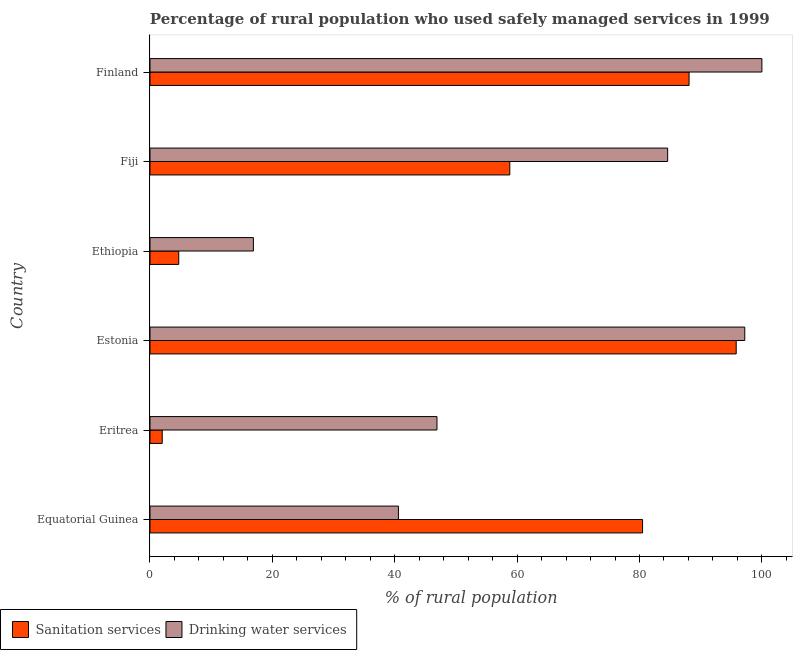Are the number of bars per tick equal to the number of legend labels?
Keep it short and to the point. Yes. What is the label of the 6th group of bars from the top?
Keep it short and to the point. Equatorial Guinea. In how many cases, is the number of bars for a given country not equal to the number of legend labels?
Make the answer very short. 0. Across all countries, what is the maximum percentage of rural population who used drinking water services?
Provide a succinct answer. 100. In which country was the percentage of rural population who used drinking water services maximum?
Your answer should be compact. Finland. In which country was the percentage of rural population who used sanitation services minimum?
Your answer should be very brief. Eritrea. What is the total percentage of rural population who used sanitation services in the graph?
Your answer should be very brief. 329.9. What is the difference between the percentage of rural population who used sanitation services in Equatorial Guinea and that in Eritrea?
Your answer should be compact. 78.5. What is the difference between the percentage of rural population who used drinking water services in Estonia and the percentage of rural population who used sanitation services in Fiji?
Ensure brevity in your answer.  38.4. What is the average percentage of rural population who used sanitation services per country?
Ensure brevity in your answer.  54.98. What is the difference between the percentage of rural population who used drinking water services and percentage of rural population who used sanitation services in Eritrea?
Your answer should be very brief. 44.9. In how many countries, is the percentage of rural population who used sanitation services greater than 68 %?
Your answer should be compact. 3. What is the ratio of the percentage of rural population who used drinking water services in Estonia to that in Finland?
Your answer should be compact. 0.97. Is the percentage of rural population who used drinking water services in Equatorial Guinea less than that in Estonia?
Keep it short and to the point. Yes. Is the difference between the percentage of rural population who used drinking water services in Eritrea and Fiji greater than the difference between the percentage of rural population who used sanitation services in Eritrea and Fiji?
Your answer should be very brief. Yes. What is the difference between the highest and the second highest percentage of rural population who used sanitation services?
Keep it short and to the point. 7.7. What is the difference between the highest and the lowest percentage of rural population who used sanitation services?
Provide a short and direct response. 93.8. In how many countries, is the percentage of rural population who used drinking water services greater than the average percentage of rural population who used drinking water services taken over all countries?
Your answer should be compact. 3. Is the sum of the percentage of rural population who used sanitation services in Equatorial Guinea and Ethiopia greater than the maximum percentage of rural population who used drinking water services across all countries?
Provide a short and direct response. No. What does the 2nd bar from the top in Eritrea represents?
Keep it short and to the point. Sanitation services. What does the 2nd bar from the bottom in Finland represents?
Give a very brief answer. Drinking water services. What is the difference between two consecutive major ticks on the X-axis?
Offer a very short reply. 20. Are the values on the major ticks of X-axis written in scientific E-notation?
Ensure brevity in your answer.  No. Does the graph contain grids?
Your answer should be very brief. No. Where does the legend appear in the graph?
Ensure brevity in your answer.  Bottom left. How many legend labels are there?
Ensure brevity in your answer.  2. What is the title of the graph?
Ensure brevity in your answer.  Percentage of rural population who used safely managed services in 1999. Does "Automatic Teller Machines" appear as one of the legend labels in the graph?
Ensure brevity in your answer.  No. What is the label or title of the X-axis?
Your answer should be very brief. % of rural population. What is the % of rural population of Sanitation services in Equatorial Guinea?
Keep it short and to the point. 80.5. What is the % of rural population of Drinking water services in Equatorial Guinea?
Ensure brevity in your answer.  40.6. What is the % of rural population in Drinking water services in Eritrea?
Make the answer very short. 46.9. What is the % of rural population in Sanitation services in Estonia?
Make the answer very short. 95.8. What is the % of rural population in Drinking water services in Estonia?
Make the answer very short. 97.2. What is the % of rural population in Drinking water services in Ethiopia?
Keep it short and to the point. 16.9. What is the % of rural population in Sanitation services in Fiji?
Ensure brevity in your answer.  58.8. What is the % of rural population of Drinking water services in Fiji?
Your answer should be very brief. 84.6. What is the % of rural population in Sanitation services in Finland?
Your response must be concise. 88.1. What is the % of rural population of Drinking water services in Finland?
Your response must be concise. 100. Across all countries, what is the maximum % of rural population in Sanitation services?
Give a very brief answer. 95.8. Across all countries, what is the maximum % of rural population in Drinking water services?
Make the answer very short. 100. What is the total % of rural population of Sanitation services in the graph?
Give a very brief answer. 329.9. What is the total % of rural population of Drinking water services in the graph?
Offer a terse response. 386.2. What is the difference between the % of rural population in Sanitation services in Equatorial Guinea and that in Eritrea?
Ensure brevity in your answer.  78.5. What is the difference between the % of rural population in Sanitation services in Equatorial Guinea and that in Estonia?
Your answer should be very brief. -15.3. What is the difference between the % of rural population in Drinking water services in Equatorial Guinea and that in Estonia?
Provide a succinct answer. -56.6. What is the difference between the % of rural population of Sanitation services in Equatorial Guinea and that in Ethiopia?
Provide a short and direct response. 75.8. What is the difference between the % of rural population of Drinking water services in Equatorial Guinea and that in Ethiopia?
Provide a succinct answer. 23.7. What is the difference between the % of rural population of Sanitation services in Equatorial Guinea and that in Fiji?
Your answer should be very brief. 21.7. What is the difference between the % of rural population in Drinking water services in Equatorial Guinea and that in Fiji?
Offer a very short reply. -44. What is the difference between the % of rural population of Drinking water services in Equatorial Guinea and that in Finland?
Provide a short and direct response. -59.4. What is the difference between the % of rural population of Sanitation services in Eritrea and that in Estonia?
Your answer should be compact. -93.8. What is the difference between the % of rural population of Drinking water services in Eritrea and that in Estonia?
Make the answer very short. -50.3. What is the difference between the % of rural population of Sanitation services in Eritrea and that in Fiji?
Provide a short and direct response. -56.8. What is the difference between the % of rural population in Drinking water services in Eritrea and that in Fiji?
Your response must be concise. -37.7. What is the difference between the % of rural population in Sanitation services in Eritrea and that in Finland?
Offer a terse response. -86.1. What is the difference between the % of rural population in Drinking water services in Eritrea and that in Finland?
Provide a succinct answer. -53.1. What is the difference between the % of rural population in Sanitation services in Estonia and that in Ethiopia?
Ensure brevity in your answer.  91.1. What is the difference between the % of rural population in Drinking water services in Estonia and that in Ethiopia?
Your answer should be very brief. 80.3. What is the difference between the % of rural population of Sanitation services in Estonia and that in Fiji?
Your answer should be very brief. 37. What is the difference between the % of rural population of Drinking water services in Estonia and that in Finland?
Provide a short and direct response. -2.8. What is the difference between the % of rural population in Sanitation services in Ethiopia and that in Fiji?
Your answer should be compact. -54.1. What is the difference between the % of rural population of Drinking water services in Ethiopia and that in Fiji?
Make the answer very short. -67.7. What is the difference between the % of rural population in Sanitation services in Ethiopia and that in Finland?
Offer a very short reply. -83.4. What is the difference between the % of rural population of Drinking water services in Ethiopia and that in Finland?
Keep it short and to the point. -83.1. What is the difference between the % of rural population in Sanitation services in Fiji and that in Finland?
Give a very brief answer. -29.3. What is the difference between the % of rural population of Drinking water services in Fiji and that in Finland?
Make the answer very short. -15.4. What is the difference between the % of rural population in Sanitation services in Equatorial Guinea and the % of rural population in Drinking water services in Eritrea?
Give a very brief answer. 33.6. What is the difference between the % of rural population in Sanitation services in Equatorial Guinea and the % of rural population in Drinking water services in Estonia?
Your answer should be compact. -16.7. What is the difference between the % of rural population of Sanitation services in Equatorial Guinea and the % of rural population of Drinking water services in Ethiopia?
Provide a short and direct response. 63.6. What is the difference between the % of rural population of Sanitation services in Equatorial Guinea and the % of rural population of Drinking water services in Finland?
Offer a terse response. -19.5. What is the difference between the % of rural population in Sanitation services in Eritrea and the % of rural population in Drinking water services in Estonia?
Your answer should be very brief. -95.2. What is the difference between the % of rural population in Sanitation services in Eritrea and the % of rural population in Drinking water services in Ethiopia?
Make the answer very short. -14.9. What is the difference between the % of rural population in Sanitation services in Eritrea and the % of rural population in Drinking water services in Fiji?
Keep it short and to the point. -82.6. What is the difference between the % of rural population of Sanitation services in Eritrea and the % of rural population of Drinking water services in Finland?
Give a very brief answer. -98. What is the difference between the % of rural population of Sanitation services in Estonia and the % of rural population of Drinking water services in Ethiopia?
Offer a very short reply. 78.9. What is the difference between the % of rural population in Sanitation services in Estonia and the % of rural population in Drinking water services in Fiji?
Provide a short and direct response. 11.2. What is the difference between the % of rural population of Sanitation services in Ethiopia and the % of rural population of Drinking water services in Fiji?
Provide a succinct answer. -79.9. What is the difference between the % of rural population of Sanitation services in Ethiopia and the % of rural population of Drinking water services in Finland?
Provide a short and direct response. -95.3. What is the difference between the % of rural population of Sanitation services in Fiji and the % of rural population of Drinking water services in Finland?
Your answer should be very brief. -41.2. What is the average % of rural population of Sanitation services per country?
Make the answer very short. 54.98. What is the average % of rural population in Drinking water services per country?
Make the answer very short. 64.37. What is the difference between the % of rural population of Sanitation services and % of rural population of Drinking water services in Equatorial Guinea?
Provide a short and direct response. 39.9. What is the difference between the % of rural population of Sanitation services and % of rural population of Drinking water services in Eritrea?
Your response must be concise. -44.9. What is the difference between the % of rural population of Sanitation services and % of rural population of Drinking water services in Estonia?
Provide a short and direct response. -1.4. What is the difference between the % of rural population of Sanitation services and % of rural population of Drinking water services in Ethiopia?
Your answer should be very brief. -12.2. What is the difference between the % of rural population in Sanitation services and % of rural population in Drinking water services in Fiji?
Offer a terse response. -25.8. What is the difference between the % of rural population in Sanitation services and % of rural population in Drinking water services in Finland?
Your answer should be compact. -11.9. What is the ratio of the % of rural population in Sanitation services in Equatorial Guinea to that in Eritrea?
Your response must be concise. 40.25. What is the ratio of the % of rural population in Drinking water services in Equatorial Guinea to that in Eritrea?
Give a very brief answer. 0.87. What is the ratio of the % of rural population of Sanitation services in Equatorial Guinea to that in Estonia?
Provide a short and direct response. 0.84. What is the ratio of the % of rural population in Drinking water services in Equatorial Guinea to that in Estonia?
Keep it short and to the point. 0.42. What is the ratio of the % of rural population of Sanitation services in Equatorial Guinea to that in Ethiopia?
Ensure brevity in your answer.  17.13. What is the ratio of the % of rural population in Drinking water services in Equatorial Guinea to that in Ethiopia?
Offer a terse response. 2.4. What is the ratio of the % of rural population of Sanitation services in Equatorial Guinea to that in Fiji?
Give a very brief answer. 1.37. What is the ratio of the % of rural population of Drinking water services in Equatorial Guinea to that in Fiji?
Your answer should be compact. 0.48. What is the ratio of the % of rural population of Sanitation services in Equatorial Guinea to that in Finland?
Give a very brief answer. 0.91. What is the ratio of the % of rural population in Drinking water services in Equatorial Guinea to that in Finland?
Offer a terse response. 0.41. What is the ratio of the % of rural population in Sanitation services in Eritrea to that in Estonia?
Make the answer very short. 0.02. What is the ratio of the % of rural population in Drinking water services in Eritrea to that in Estonia?
Keep it short and to the point. 0.48. What is the ratio of the % of rural population of Sanitation services in Eritrea to that in Ethiopia?
Provide a short and direct response. 0.43. What is the ratio of the % of rural population of Drinking water services in Eritrea to that in Ethiopia?
Provide a short and direct response. 2.78. What is the ratio of the % of rural population in Sanitation services in Eritrea to that in Fiji?
Your answer should be compact. 0.03. What is the ratio of the % of rural population of Drinking water services in Eritrea to that in Fiji?
Your answer should be very brief. 0.55. What is the ratio of the % of rural population of Sanitation services in Eritrea to that in Finland?
Keep it short and to the point. 0.02. What is the ratio of the % of rural population of Drinking water services in Eritrea to that in Finland?
Provide a succinct answer. 0.47. What is the ratio of the % of rural population in Sanitation services in Estonia to that in Ethiopia?
Make the answer very short. 20.38. What is the ratio of the % of rural population of Drinking water services in Estonia to that in Ethiopia?
Ensure brevity in your answer.  5.75. What is the ratio of the % of rural population of Sanitation services in Estonia to that in Fiji?
Provide a succinct answer. 1.63. What is the ratio of the % of rural population in Drinking water services in Estonia to that in Fiji?
Your answer should be very brief. 1.15. What is the ratio of the % of rural population in Sanitation services in Estonia to that in Finland?
Ensure brevity in your answer.  1.09. What is the ratio of the % of rural population in Sanitation services in Ethiopia to that in Fiji?
Give a very brief answer. 0.08. What is the ratio of the % of rural population in Drinking water services in Ethiopia to that in Fiji?
Keep it short and to the point. 0.2. What is the ratio of the % of rural population of Sanitation services in Ethiopia to that in Finland?
Keep it short and to the point. 0.05. What is the ratio of the % of rural population in Drinking water services in Ethiopia to that in Finland?
Offer a terse response. 0.17. What is the ratio of the % of rural population of Sanitation services in Fiji to that in Finland?
Keep it short and to the point. 0.67. What is the ratio of the % of rural population in Drinking water services in Fiji to that in Finland?
Give a very brief answer. 0.85. What is the difference between the highest and the second highest % of rural population in Sanitation services?
Ensure brevity in your answer.  7.7. What is the difference between the highest and the second highest % of rural population of Drinking water services?
Offer a very short reply. 2.8. What is the difference between the highest and the lowest % of rural population of Sanitation services?
Provide a short and direct response. 93.8. What is the difference between the highest and the lowest % of rural population in Drinking water services?
Your answer should be very brief. 83.1. 